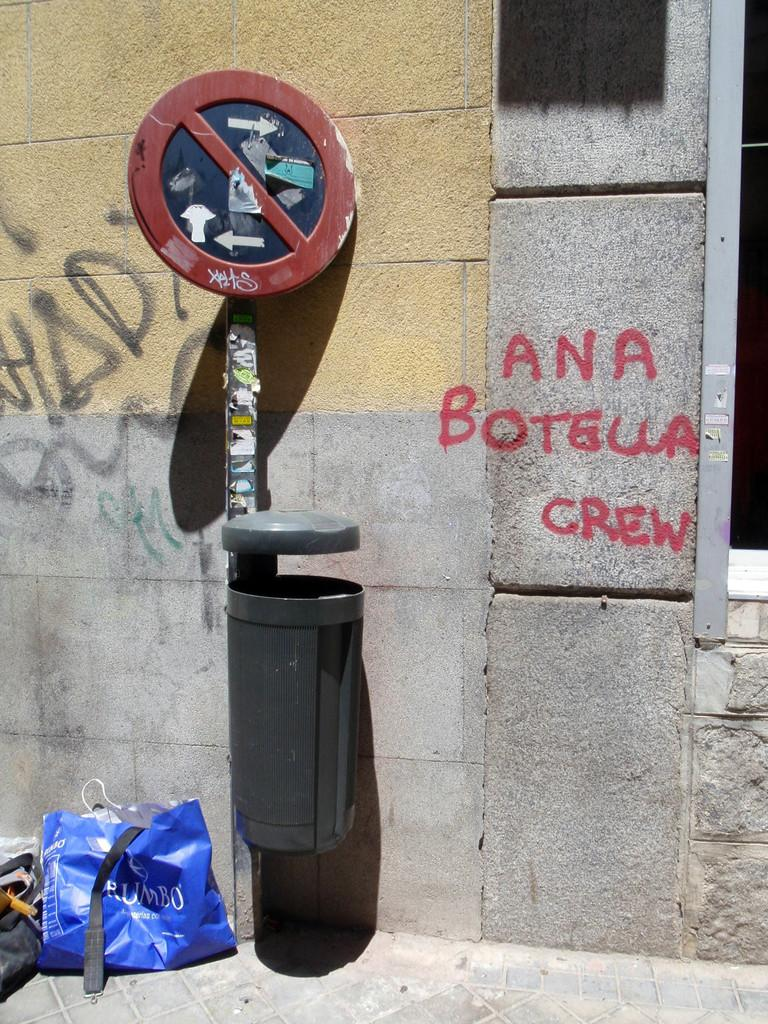<image>
Provide a brief description of the given image. a little bin next to some graffiti, some of which reads Ana Botella Crew 